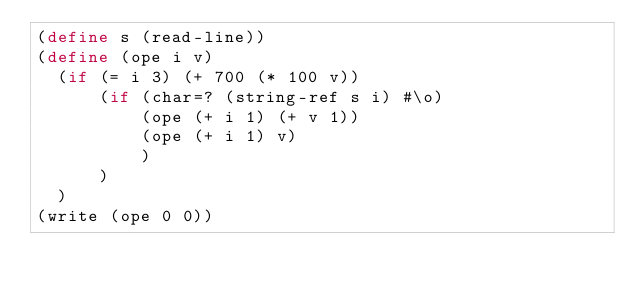<code> <loc_0><loc_0><loc_500><loc_500><_Scheme_>(define s (read-line))
(define (ope i v)
  (if (= i 3) (+ 700 (* 100 v)) 
      (if (char=? (string-ref s i) #\o)
          (ope (+ i 1) (+ v 1))
          (ope (+ i 1) v)
          )
      )
  )
(write (ope 0 0))</code> 